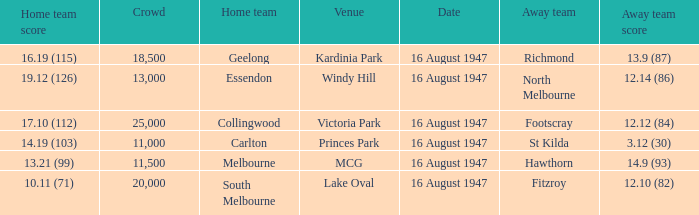What venue had footscray play at it? Victoria Park. 